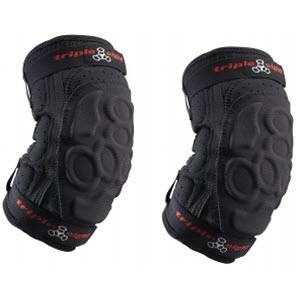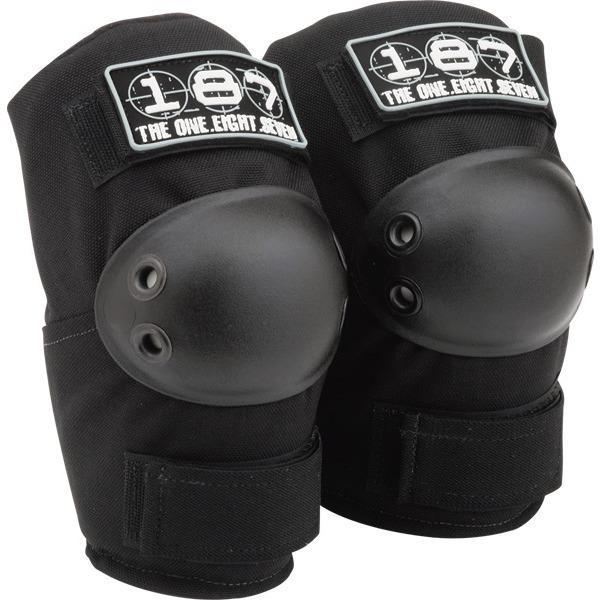The first image is the image on the left, the second image is the image on the right. For the images shown, is this caption "All the pads are facing right." true? Answer yes or no. Yes. 